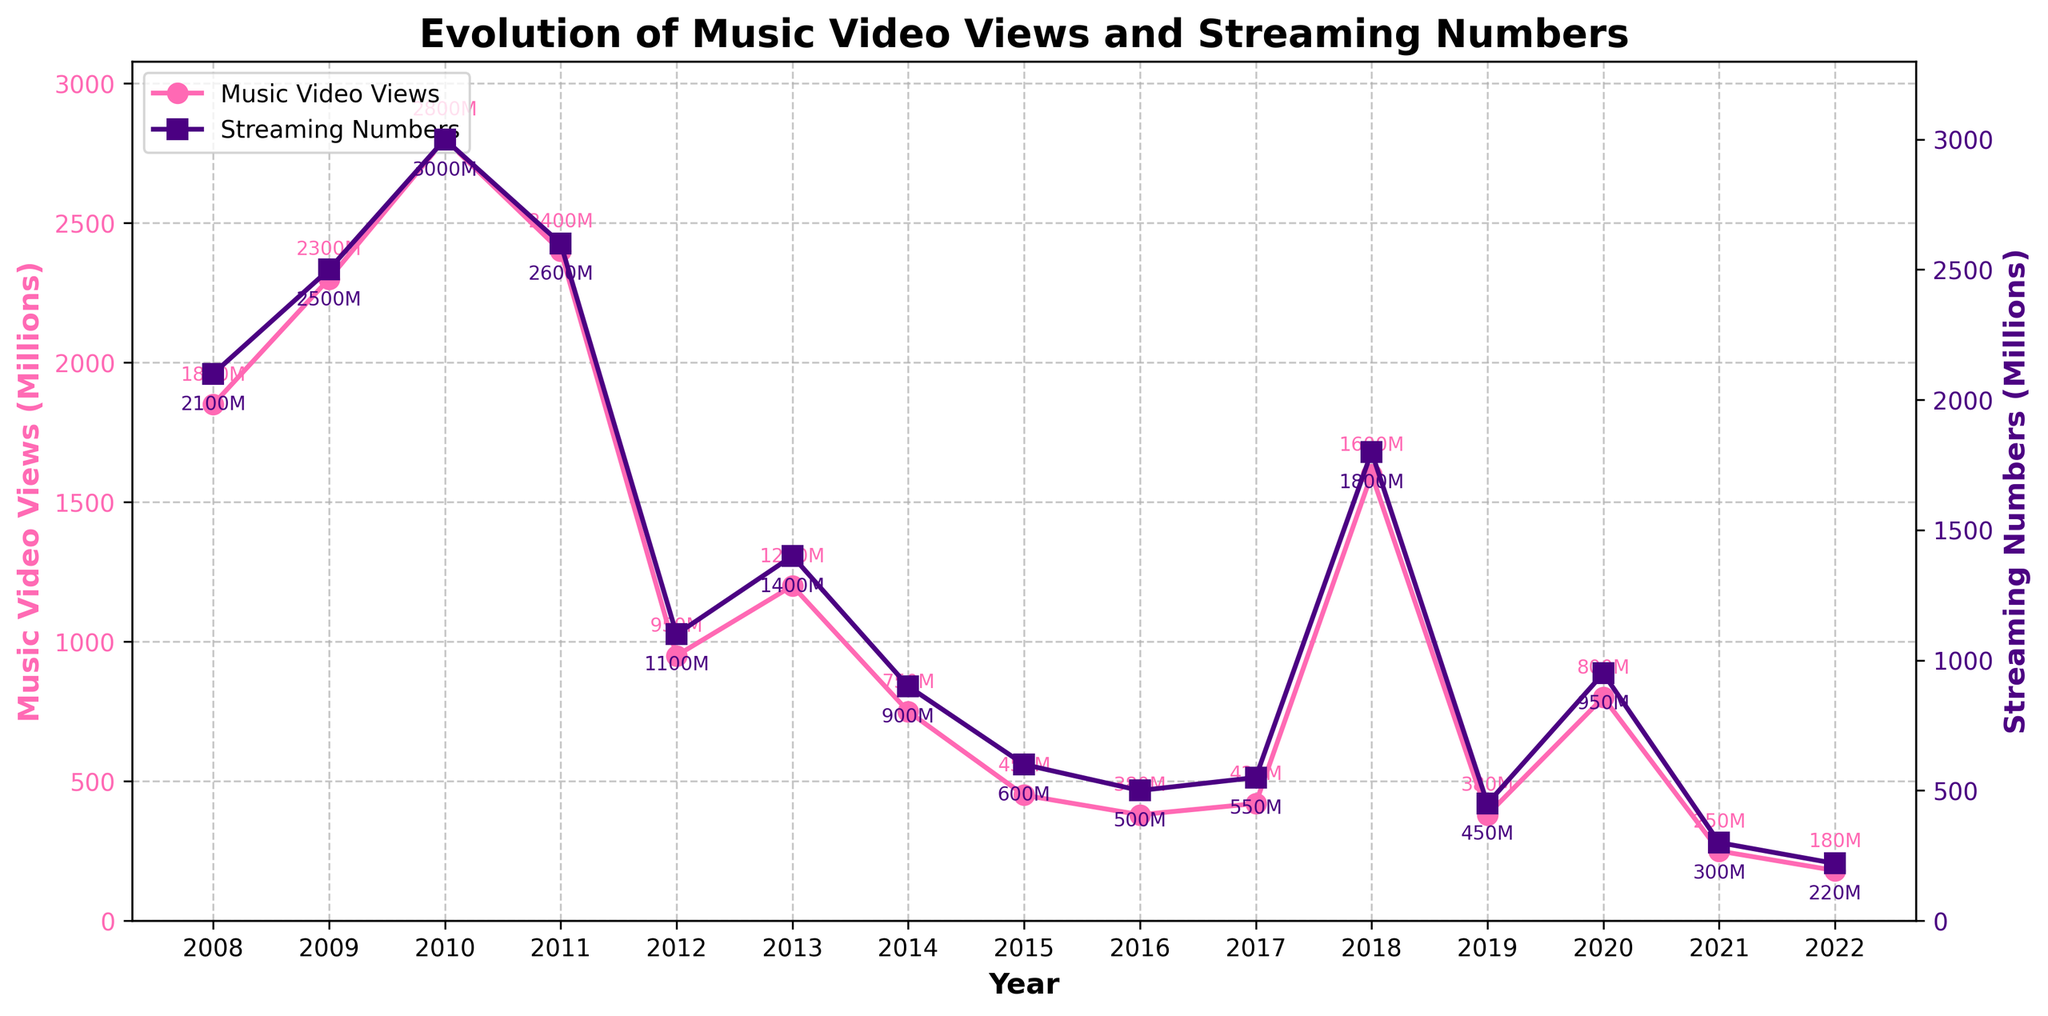What is the single with the highest music video views? First, locate the line representing music video views on the chart. Then identify the highest point on this line and check the corresponding year. The highest point is at 2010, which is "Bad Romance".
Answer: Bad Romance Which year saw the largest drop in music video views from the previous year? Start by finding the year-to-year differences in the music video views. The largest drop is between 2010 (2800M) and 2011 (2400M), which is 400M.
Answer: 2011 By how much did streaming numbers increase from 2017 to 2018? Find the streaming numbers for 2017 (The Cure: 550M) and 2018 (Shallow: 1800M). Compute the difference: 1800M - 550M = 1250M.
Answer: 1250M Which single had significantly lower music video views compared to its adjacent years? Look for singles where the music video views are substantially lower than the singles in the preceding and following years. "You and I" in 2012 had 950M views, which is significantly lower compared to "Born This Way" in 2011 (2400M) and "Applause" in 2013 (1200M).
Answer: You and I How does the trend in music video views compare with the trend in streaming numbers over time? Analyze both lines on the chart. Initially, both trends were high and increased until around 2010. Post-2010, music video views generally decreased while streaming numbers fluctuated. Recent years show a decline in both trends.
Answer: Initially similar, but music video views decreased over time while streaming numbers fluctuated but remained relatively high longer Which year had the lowest streaming numbers, and what was the count? Identify the lowest point on the streaming numbers line. The lowest point is in 2022 with "Love For Sale", which had 220M streaming numbers.
Answer: 2022, 220M What patterns or trends can you observe about the relationship between music video views and streaming numbers for each single? Generally, both metrics show peaks for the earlier years (2008-2011). There's a notable dip in both metrics in 2012 and a mixed trend thereafter, with an occasional spike such as in 2018 for "Shallow".
Answer: Peaks in early years, dip in 2012, mixed trend afterward with a spike in 2018 Are there any singles where music video views and streaming numbers differ considerably? Look for points where the distances between the lines of music video views and streaming numbers are the greatest. For instance, in 2010, "Bad Romance" had 2800M views and 3000M streams, and in 2018, "Shallow" had 1600M views and 1800M streams.
Answer: Bad Romance, Shallow 